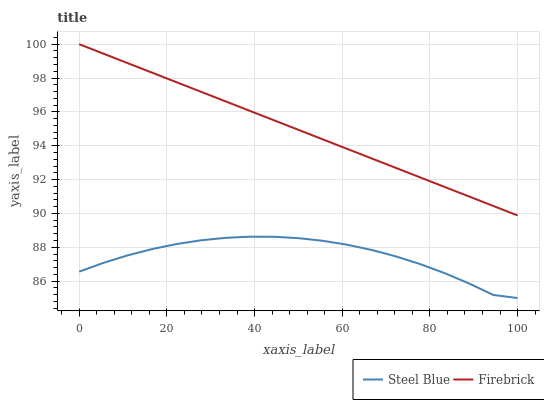Does Steel Blue have the minimum area under the curve?
Answer yes or no. Yes. Does Firebrick have the maximum area under the curve?
Answer yes or no. Yes. Does Steel Blue have the maximum area under the curve?
Answer yes or no. No. Is Firebrick the smoothest?
Answer yes or no. Yes. Is Steel Blue the roughest?
Answer yes or no. Yes. Is Steel Blue the smoothest?
Answer yes or no. No. Does Steel Blue have the lowest value?
Answer yes or no. Yes. Does Firebrick have the highest value?
Answer yes or no. Yes. Does Steel Blue have the highest value?
Answer yes or no. No. Is Steel Blue less than Firebrick?
Answer yes or no. Yes. Is Firebrick greater than Steel Blue?
Answer yes or no. Yes. Does Steel Blue intersect Firebrick?
Answer yes or no. No. 